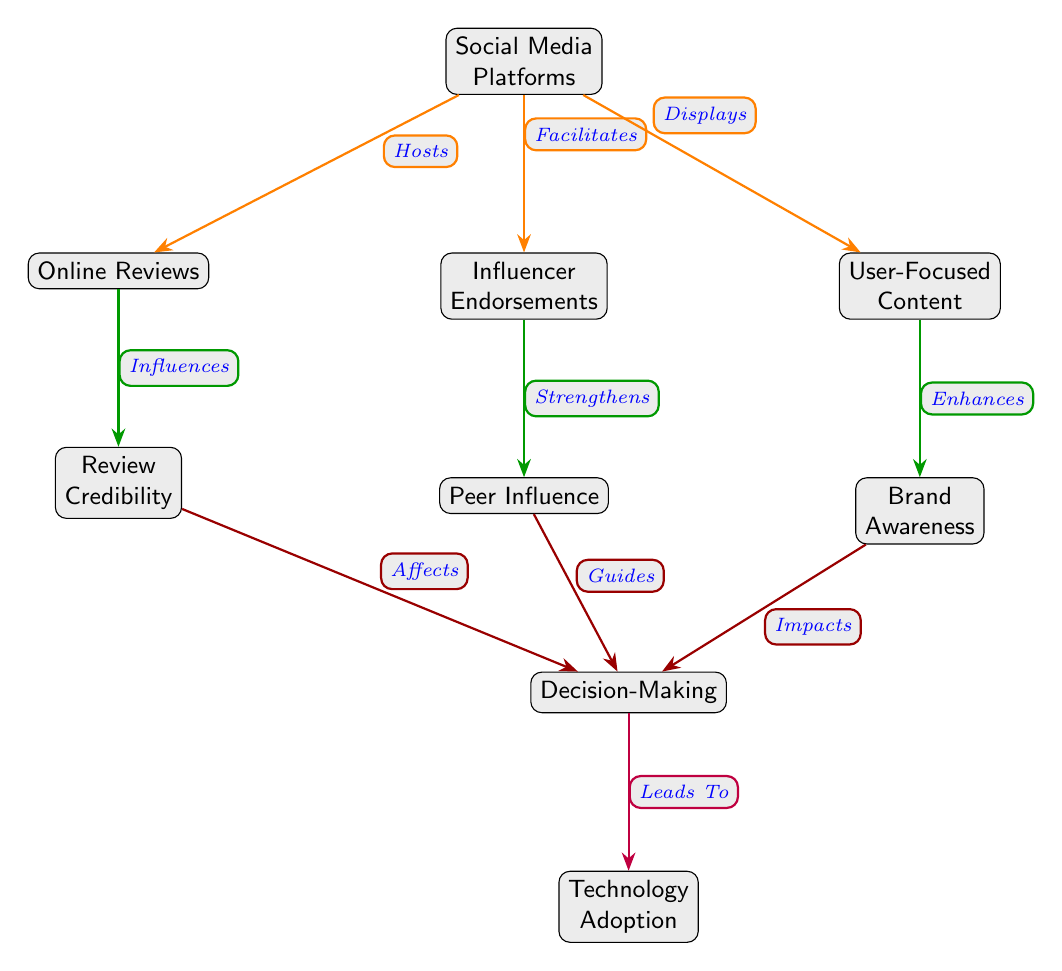What are the nodes directly influenced by Social Media Platforms? The nodes that are directly connected to Social Media Platforms are Online Reviews, Influencer Endorsements, and User-Focused Content. These nodes are connected to Social Media Platforms through edges labeled "Hosts," "Facilitates," and "Displays," respectively.
Answer: Online Reviews, Influencer Endorsements, User-Focused Content How many total nodes are in the diagram? The total number of nodes in the diagram includes Social Media Platforms, Online Reviews, Influencer Endorsements, User-Focused Content, Review Credibility, Peer Influence, Brand Awareness, Decision-Making, and Technology Adoption. Therefore, there are 9 nodes in total.
Answer: 9 What role does Review Credibility play in the diagram? Review Credibility is influenced by Online Reviews, shown by the edge labeled "Influences." Additionally, Review Credibility affects Decision-Making, indicated by the edge labeled "Affects." This means that Review Credibility is a factor that guides the decision-making process.
Answer: Influences Decision-Making Which node is at the end of the flow in the diagram? The flow in the diagram culminates in the node labeled Technology Adoption, which is directly connected to the Decision-Making node with an edge labeled "Leads To." It signifies the ultimate outcome of the decision-making process in the context of technology adoption.
Answer: Technology Adoption What is the relationship between Influencer Endorsements and Decision-Making? Influencer Endorsements are connected to Peer Influence, which in turn guides Decision-Making. The edge labeled "Strengthens" indicates that Influencer Endorsements enhance Peer Influence, ultimately leading to its influence on Decision-Making. Thus, the connection is one of support and guidance.
Answer: Guides Decision-Making Which node enhances Brand Awareness? User-Focused Content is the node that enhances Brand Awareness. This relationship is shown by the edge labeled "Enhances," which indicates that User-Focused Content positively contributes to the awareness of the brand.
Answer: User-Focused Content 